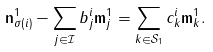<formula> <loc_0><loc_0><loc_500><loc_500>\mathbf n ^ { 1 } _ { \sigma ( i ) } - \sum _ { j \in \mathcal { I } } b _ { j } ^ { i } \mathbf m _ { j } ^ { 1 } = \sum _ { k \in \mathcal { S } _ { 1 } } c _ { k } ^ { i } \mathbf m ^ { 1 } _ { k } .</formula> 